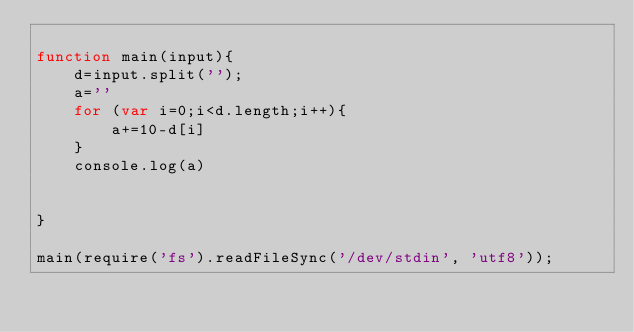Convert code to text. <code><loc_0><loc_0><loc_500><loc_500><_JavaScript_>
function main(input){
    d=input.split('');
    a=''
    for (var i=0;i<d.length;i++){
        a+=10-d[i]
    }
    console.log(a)


}

main(require('fs').readFileSync('/dev/stdin', 'utf8'));</code> 